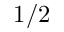<formula> <loc_0><loc_0><loc_500><loc_500>1 / 2</formula> 